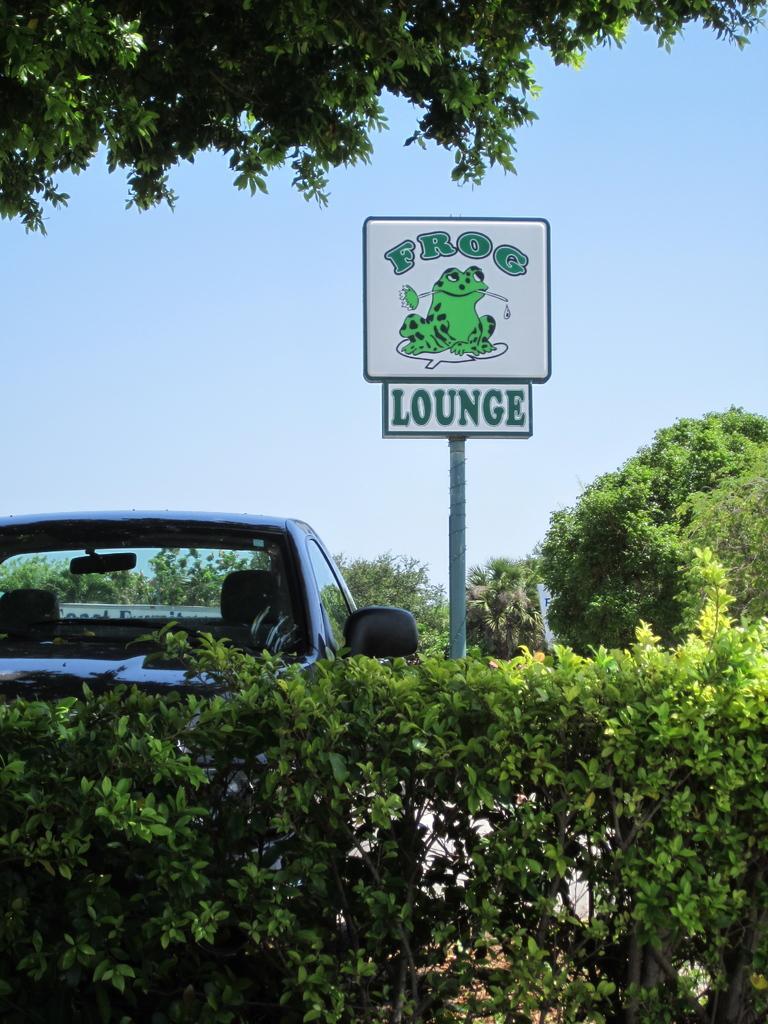Could you give a brief overview of what you see in this image? In this image we can see plants, cat, trees and board. Behind the board, the sky is in blue color. There is a tree at the top of the image. 